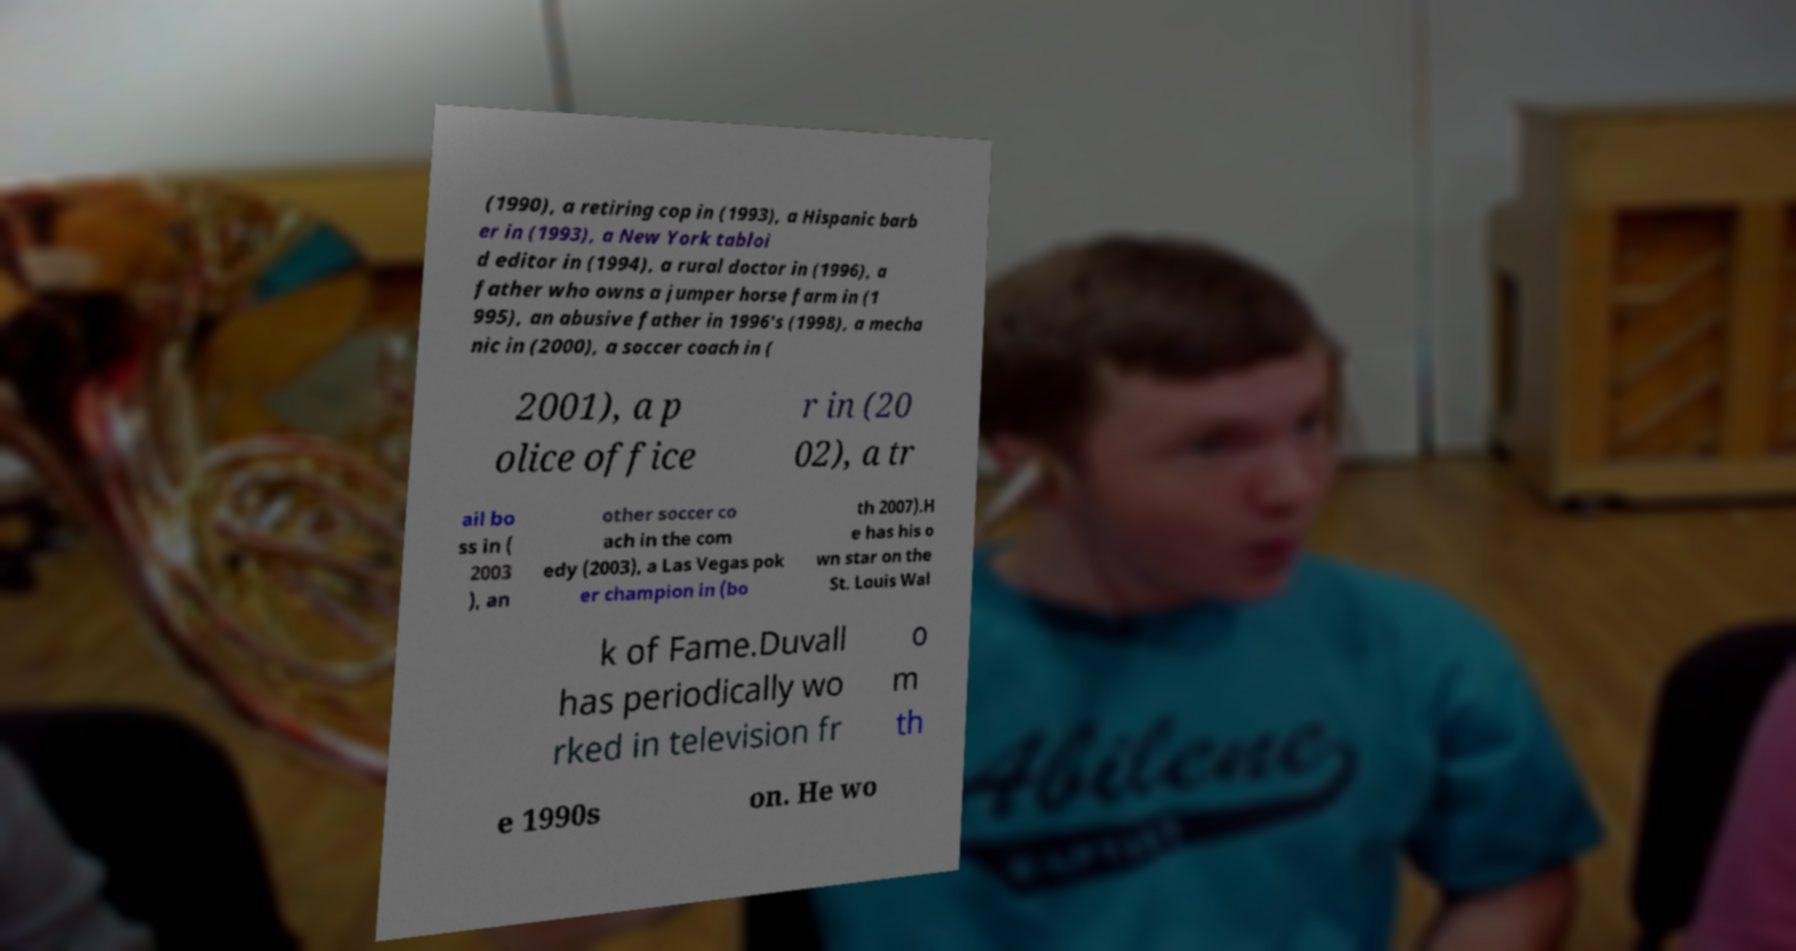There's text embedded in this image that I need extracted. Can you transcribe it verbatim? (1990), a retiring cop in (1993), a Hispanic barb er in (1993), a New York tabloi d editor in (1994), a rural doctor in (1996), a father who owns a jumper horse farm in (1 995), an abusive father in 1996's (1998), a mecha nic in (2000), a soccer coach in ( 2001), a p olice office r in (20 02), a tr ail bo ss in ( 2003 ), an other soccer co ach in the com edy (2003), a Las Vegas pok er champion in (bo th 2007).H e has his o wn star on the St. Louis Wal k of Fame.Duvall has periodically wo rked in television fr o m th e 1990s on. He wo 